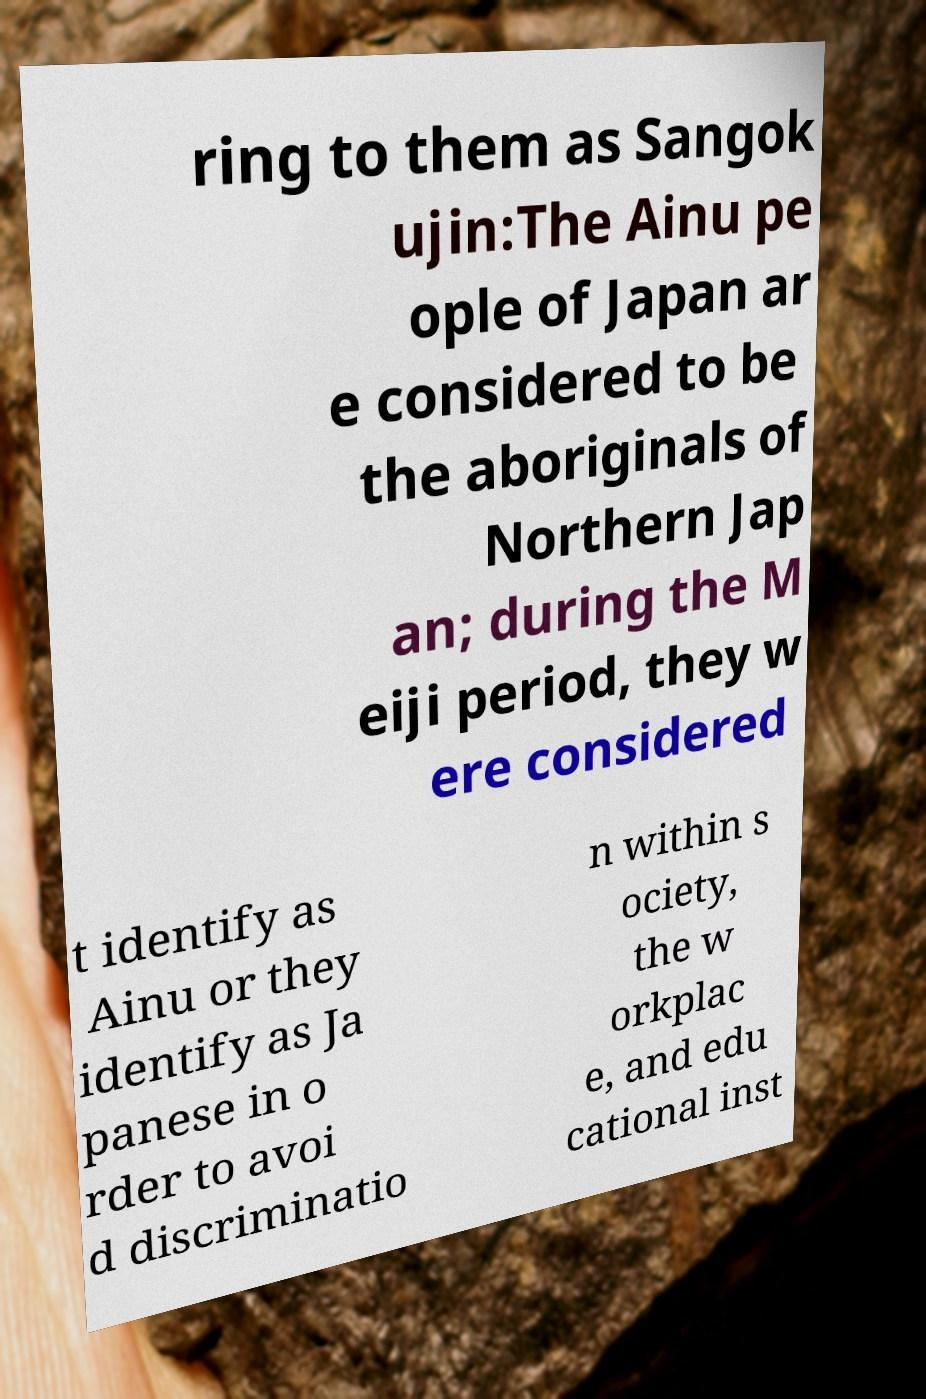Can you read and provide the text displayed in the image?This photo seems to have some interesting text. Can you extract and type it out for me? ring to them as Sangok ujin:The Ainu pe ople of Japan ar e considered to be the aboriginals of Northern Jap an; during the M eiji period, they w ere considered t identify as Ainu or they identify as Ja panese in o rder to avoi d discriminatio n within s ociety, the w orkplac e, and edu cational inst 